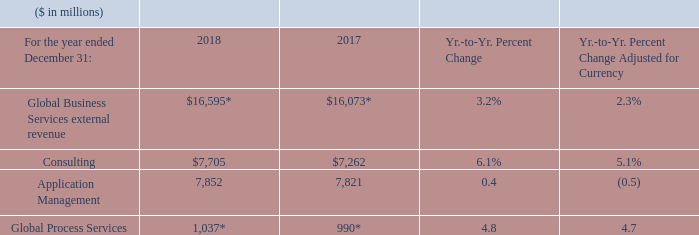Global Business Services
* Recast to reflect segment changes.
Global Business Services revenue increased compared to 2017 driven by strong growth in Consulting, led by key offerings in digital Global Business Services revenue increased compared to 2017 driven by strong growth in Consulting, led by key offerings in digital and cloud application, where the business has brought together technology and industry expertise to help clients on their digital journey. GPS grew year to year, while Application Management revenue was flat as reported and declined adjusted for currency compared to 2017.
While we continued to help clients move to the cloud with offerings such as Cloud Migration Factory and cloud application development, there were continued declines in the more traditional application management engagements. Within GBS, cloud revenue of $4.7 billion grew 20 percent as reported and 19 percent adjusted for currency compared to the prior year.
What caused the increase in Global Business Services revenue? Driven by strong growth in consulting, led by key offerings in digital global business services revenue increased compared to 2017 driven by strong growth in consulting, led by key offerings in digital and cloud application, where the business has brought together technology and industry expertise to help clients on their digital journey. What was the impact on GPS and Application Management revenue? Gps grew year to year, while application management revenue was flat as reported and declined adjusted for currency compared to 2017. What was the percentage growth in GBS Cloud revenue? 20 percent. What is the increase / (decrease) in the Global Business Services external revenue from 2017 to 2018?
Answer scale should be: million. 16,595 - 16,073
Answer: 522. What is the average consulting?
Answer scale should be: million. (7,705 + 7,262) / 2
Answer: 7483.5. What percentage of total Global Business Services external revenue was Application Management in 2018?
Answer scale should be: percent. 7,705 / 16,595
Answer: 46.43. 